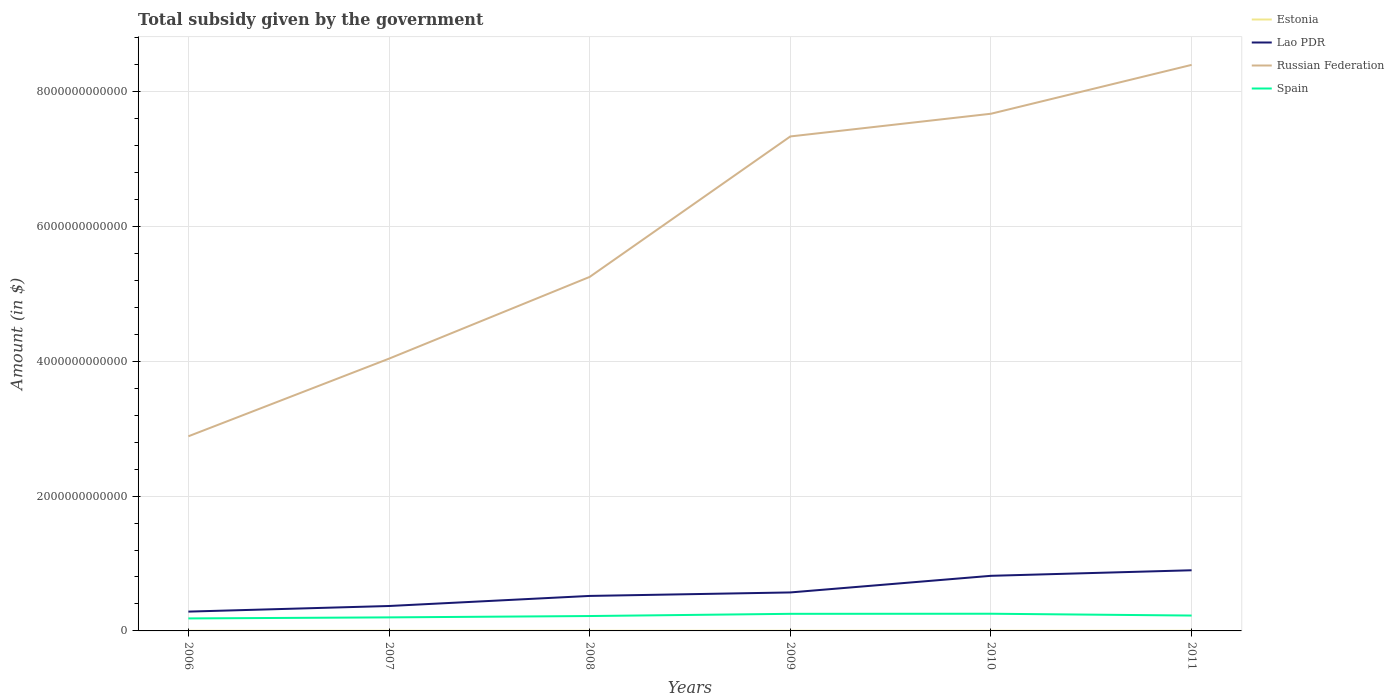Across all years, what is the maximum total revenue collected by the government in Lao PDR?
Ensure brevity in your answer.  2.87e+11. In which year was the total revenue collected by the government in Russian Federation maximum?
Give a very brief answer. 2006. What is the total total revenue collected by the government in Estonia in the graph?
Give a very brief answer. 3.53e+08. What is the difference between the highest and the second highest total revenue collected by the government in Lao PDR?
Keep it short and to the point. 6.13e+11. What is the difference between the highest and the lowest total revenue collected by the government in Estonia?
Make the answer very short. 2. Is the total revenue collected by the government in Estonia strictly greater than the total revenue collected by the government in Lao PDR over the years?
Your response must be concise. Yes. How many lines are there?
Provide a succinct answer. 4. What is the difference between two consecutive major ticks on the Y-axis?
Your answer should be compact. 2.00e+12. Does the graph contain any zero values?
Provide a short and direct response. No. Where does the legend appear in the graph?
Offer a very short reply. Top right. How many legend labels are there?
Ensure brevity in your answer.  4. How are the legend labels stacked?
Keep it short and to the point. Vertical. What is the title of the graph?
Ensure brevity in your answer.  Total subsidy given by the government. What is the label or title of the X-axis?
Your answer should be compact. Years. What is the label or title of the Y-axis?
Keep it short and to the point. Amount (in $). What is the Amount (in $) of Estonia in 2006?
Offer a very short reply. 2.17e+09. What is the Amount (in $) of Lao PDR in 2006?
Your answer should be very brief. 2.87e+11. What is the Amount (in $) in Russian Federation in 2006?
Offer a very short reply. 2.89e+12. What is the Amount (in $) in Spain in 2006?
Make the answer very short. 1.85e+11. What is the Amount (in $) in Estonia in 2007?
Make the answer very short. 2.59e+09. What is the Amount (in $) of Lao PDR in 2007?
Give a very brief answer. 3.70e+11. What is the Amount (in $) in Russian Federation in 2007?
Make the answer very short. 4.04e+12. What is the Amount (in $) of Spain in 2007?
Your response must be concise. 2.01e+11. What is the Amount (in $) in Estonia in 2008?
Ensure brevity in your answer.  2.03e+09. What is the Amount (in $) of Lao PDR in 2008?
Your response must be concise. 5.19e+11. What is the Amount (in $) in Russian Federation in 2008?
Offer a very short reply. 5.25e+12. What is the Amount (in $) of Spain in 2008?
Give a very brief answer. 2.21e+11. What is the Amount (in $) of Estonia in 2009?
Make the answer very short. 2.23e+09. What is the Amount (in $) of Lao PDR in 2009?
Keep it short and to the point. 5.71e+11. What is the Amount (in $) in Russian Federation in 2009?
Your answer should be compact. 7.33e+12. What is the Amount (in $) in Spain in 2009?
Provide a succinct answer. 2.54e+11. What is the Amount (in $) in Estonia in 2010?
Offer a terse response. 2.18e+09. What is the Amount (in $) of Lao PDR in 2010?
Keep it short and to the point. 8.17e+11. What is the Amount (in $) in Russian Federation in 2010?
Provide a succinct answer. 7.67e+12. What is the Amount (in $) in Spain in 2010?
Ensure brevity in your answer.  2.55e+11. What is the Amount (in $) in Estonia in 2011?
Offer a terse response. 2.20e+09. What is the Amount (in $) of Lao PDR in 2011?
Provide a succinct answer. 9.00e+11. What is the Amount (in $) of Russian Federation in 2011?
Offer a terse response. 8.40e+12. What is the Amount (in $) in Spain in 2011?
Your answer should be very brief. 2.28e+11. Across all years, what is the maximum Amount (in $) of Estonia?
Keep it short and to the point. 2.59e+09. Across all years, what is the maximum Amount (in $) in Lao PDR?
Ensure brevity in your answer.  9.00e+11. Across all years, what is the maximum Amount (in $) in Russian Federation?
Make the answer very short. 8.40e+12. Across all years, what is the maximum Amount (in $) of Spain?
Your answer should be very brief. 2.55e+11. Across all years, what is the minimum Amount (in $) of Estonia?
Give a very brief answer. 2.03e+09. Across all years, what is the minimum Amount (in $) of Lao PDR?
Provide a short and direct response. 2.87e+11. Across all years, what is the minimum Amount (in $) in Russian Federation?
Keep it short and to the point. 2.89e+12. Across all years, what is the minimum Amount (in $) of Spain?
Your answer should be compact. 1.85e+11. What is the total Amount (in $) of Estonia in the graph?
Offer a very short reply. 1.34e+1. What is the total Amount (in $) of Lao PDR in the graph?
Your answer should be compact. 3.46e+12. What is the total Amount (in $) of Russian Federation in the graph?
Your answer should be very brief. 3.56e+13. What is the total Amount (in $) of Spain in the graph?
Your answer should be compact. 1.34e+12. What is the difference between the Amount (in $) in Estonia in 2006 and that in 2007?
Provide a succinct answer. -4.19e+08. What is the difference between the Amount (in $) in Lao PDR in 2006 and that in 2007?
Ensure brevity in your answer.  -8.32e+1. What is the difference between the Amount (in $) of Russian Federation in 2006 and that in 2007?
Offer a very short reply. -1.15e+12. What is the difference between the Amount (in $) of Spain in 2006 and that in 2007?
Your answer should be very brief. -1.56e+1. What is the difference between the Amount (in $) of Estonia in 2006 and that in 2008?
Offer a terse response. 1.40e+08. What is the difference between the Amount (in $) of Lao PDR in 2006 and that in 2008?
Provide a succinct answer. -2.33e+11. What is the difference between the Amount (in $) of Russian Federation in 2006 and that in 2008?
Make the answer very short. -2.36e+12. What is the difference between the Amount (in $) of Spain in 2006 and that in 2008?
Your response must be concise. -3.55e+1. What is the difference between the Amount (in $) of Estonia in 2006 and that in 2009?
Your answer should be very brief. -6.62e+07. What is the difference between the Amount (in $) in Lao PDR in 2006 and that in 2009?
Keep it short and to the point. -2.84e+11. What is the difference between the Amount (in $) in Russian Federation in 2006 and that in 2009?
Ensure brevity in your answer.  -4.45e+12. What is the difference between the Amount (in $) in Spain in 2006 and that in 2009?
Offer a very short reply. -6.81e+1. What is the difference between the Amount (in $) of Estonia in 2006 and that in 2010?
Your answer should be compact. -1.08e+07. What is the difference between the Amount (in $) in Lao PDR in 2006 and that in 2010?
Make the answer very short. -5.31e+11. What is the difference between the Amount (in $) in Russian Federation in 2006 and that in 2010?
Your answer should be very brief. -4.78e+12. What is the difference between the Amount (in $) in Spain in 2006 and that in 2010?
Provide a succinct answer. -6.94e+1. What is the difference between the Amount (in $) of Estonia in 2006 and that in 2011?
Ensure brevity in your answer.  -3.22e+07. What is the difference between the Amount (in $) of Lao PDR in 2006 and that in 2011?
Your answer should be compact. -6.13e+11. What is the difference between the Amount (in $) in Russian Federation in 2006 and that in 2011?
Offer a very short reply. -5.51e+12. What is the difference between the Amount (in $) of Spain in 2006 and that in 2011?
Provide a succinct answer. -4.26e+1. What is the difference between the Amount (in $) in Estonia in 2007 and that in 2008?
Your answer should be very brief. 5.59e+08. What is the difference between the Amount (in $) of Lao PDR in 2007 and that in 2008?
Ensure brevity in your answer.  -1.49e+11. What is the difference between the Amount (in $) in Russian Federation in 2007 and that in 2008?
Give a very brief answer. -1.21e+12. What is the difference between the Amount (in $) of Spain in 2007 and that in 2008?
Your response must be concise. -1.99e+1. What is the difference between the Amount (in $) of Estonia in 2007 and that in 2009?
Offer a very short reply. 3.53e+08. What is the difference between the Amount (in $) of Lao PDR in 2007 and that in 2009?
Your answer should be compact. -2.01e+11. What is the difference between the Amount (in $) of Russian Federation in 2007 and that in 2009?
Your answer should be compact. -3.30e+12. What is the difference between the Amount (in $) in Spain in 2007 and that in 2009?
Ensure brevity in your answer.  -5.25e+1. What is the difference between the Amount (in $) of Estonia in 2007 and that in 2010?
Provide a succinct answer. 4.08e+08. What is the difference between the Amount (in $) in Lao PDR in 2007 and that in 2010?
Offer a very short reply. -4.48e+11. What is the difference between the Amount (in $) in Russian Federation in 2007 and that in 2010?
Provide a succinct answer. -3.63e+12. What is the difference between the Amount (in $) of Spain in 2007 and that in 2010?
Offer a terse response. -5.38e+1. What is the difference between the Amount (in $) of Estonia in 2007 and that in 2011?
Provide a short and direct response. 3.87e+08. What is the difference between the Amount (in $) of Lao PDR in 2007 and that in 2011?
Give a very brief answer. -5.30e+11. What is the difference between the Amount (in $) in Russian Federation in 2007 and that in 2011?
Your answer should be very brief. -4.36e+12. What is the difference between the Amount (in $) of Spain in 2007 and that in 2011?
Your response must be concise. -2.70e+1. What is the difference between the Amount (in $) of Estonia in 2008 and that in 2009?
Keep it short and to the point. -2.07e+08. What is the difference between the Amount (in $) in Lao PDR in 2008 and that in 2009?
Your answer should be very brief. -5.17e+1. What is the difference between the Amount (in $) of Russian Federation in 2008 and that in 2009?
Make the answer very short. -2.08e+12. What is the difference between the Amount (in $) in Spain in 2008 and that in 2009?
Provide a succinct answer. -3.26e+1. What is the difference between the Amount (in $) of Estonia in 2008 and that in 2010?
Keep it short and to the point. -1.51e+08. What is the difference between the Amount (in $) of Lao PDR in 2008 and that in 2010?
Your answer should be compact. -2.98e+11. What is the difference between the Amount (in $) of Russian Federation in 2008 and that in 2010?
Provide a short and direct response. -2.42e+12. What is the difference between the Amount (in $) in Spain in 2008 and that in 2010?
Your answer should be very brief. -3.39e+1. What is the difference between the Amount (in $) in Estonia in 2008 and that in 2011?
Provide a succinct answer. -1.73e+08. What is the difference between the Amount (in $) in Lao PDR in 2008 and that in 2011?
Provide a succinct answer. -3.81e+11. What is the difference between the Amount (in $) of Russian Federation in 2008 and that in 2011?
Your answer should be very brief. -3.15e+12. What is the difference between the Amount (in $) of Spain in 2008 and that in 2011?
Offer a very short reply. -7.13e+09. What is the difference between the Amount (in $) in Estonia in 2009 and that in 2010?
Offer a terse response. 5.54e+07. What is the difference between the Amount (in $) in Lao PDR in 2009 and that in 2010?
Ensure brevity in your answer.  -2.47e+11. What is the difference between the Amount (in $) of Russian Federation in 2009 and that in 2010?
Offer a very short reply. -3.37e+11. What is the difference between the Amount (in $) in Spain in 2009 and that in 2010?
Offer a very short reply. -1.29e+09. What is the difference between the Amount (in $) of Estonia in 2009 and that in 2011?
Your answer should be compact. 3.40e+07. What is the difference between the Amount (in $) of Lao PDR in 2009 and that in 2011?
Keep it short and to the point. -3.29e+11. What is the difference between the Amount (in $) of Russian Federation in 2009 and that in 2011?
Provide a succinct answer. -1.06e+12. What is the difference between the Amount (in $) in Spain in 2009 and that in 2011?
Your answer should be compact. 2.55e+1. What is the difference between the Amount (in $) of Estonia in 2010 and that in 2011?
Offer a terse response. -2.14e+07. What is the difference between the Amount (in $) of Lao PDR in 2010 and that in 2011?
Make the answer very short. -8.24e+1. What is the difference between the Amount (in $) in Russian Federation in 2010 and that in 2011?
Provide a succinct answer. -7.25e+11. What is the difference between the Amount (in $) in Spain in 2010 and that in 2011?
Make the answer very short. 2.68e+1. What is the difference between the Amount (in $) of Estonia in 2006 and the Amount (in $) of Lao PDR in 2007?
Provide a short and direct response. -3.68e+11. What is the difference between the Amount (in $) of Estonia in 2006 and the Amount (in $) of Russian Federation in 2007?
Provide a short and direct response. -4.04e+12. What is the difference between the Amount (in $) in Estonia in 2006 and the Amount (in $) in Spain in 2007?
Offer a terse response. -1.99e+11. What is the difference between the Amount (in $) of Lao PDR in 2006 and the Amount (in $) of Russian Federation in 2007?
Make the answer very short. -3.75e+12. What is the difference between the Amount (in $) in Lao PDR in 2006 and the Amount (in $) in Spain in 2007?
Your response must be concise. 8.55e+1. What is the difference between the Amount (in $) of Russian Federation in 2006 and the Amount (in $) of Spain in 2007?
Your answer should be compact. 2.69e+12. What is the difference between the Amount (in $) in Estonia in 2006 and the Amount (in $) in Lao PDR in 2008?
Offer a terse response. -5.17e+11. What is the difference between the Amount (in $) in Estonia in 2006 and the Amount (in $) in Russian Federation in 2008?
Offer a terse response. -5.25e+12. What is the difference between the Amount (in $) of Estonia in 2006 and the Amount (in $) of Spain in 2008?
Make the answer very short. -2.19e+11. What is the difference between the Amount (in $) in Lao PDR in 2006 and the Amount (in $) in Russian Federation in 2008?
Your answer should be compact. -4.96e+12. What is the difference between the Amount (in $) in Lao PDR in 2006 and the Amount (in $) in Spain in 2008?
Offer a terse response. 6.56e+1. What is the difference between the Amount (in $) in Russian Federation in 2006 and the Amount (in $) in Spain in 2008?
Give a very brief answer. 2.67e+12. What is the difference between the Amount (in $) of Estonia in 2006 and the Amount (in $) of Lao PDR in 2009?
Offer a very short reply. -5.69e+11. What is the difference between the Amount (in $) of Estonia in 2006 and the Amount (in $) of Russian Federation in 2009?
Provide a short and direct response. -7.33e+12. What is the difference between the Amount (in $) in Estonia in 2006 and the Amount (in $) in Spain in 2009?
Offer a very short reply. -2.51e+11. What is the difference between the Amount (in $) in Lao PDR in 2006 and the Amount (in $) in Russian Federation in 2009?
Make the answer very short. -7.05e+12. What is the difference between the Amount (in $) of Lao PDR in 2006 and the Amount (in $) of Spain in 2009?
Offer a terse response. 3.30e+1. What is the difference between the Amount (in $) in Russian Federation in 2006 and the Amount (in $) in Spain in 2009?
Make the answer very short. 2.63e+12. What is the difference between the Amount (in $) in Estonia in 2006 and the Amount (in $) in Lao PDR in 2010?
Your response must be concise. -8.15e+11. What is the difference between the Amount (in $) in Estonia in 2006 and the Amount (in $) in Russian Federation in 2010?
Your answer should be very brief. -7.67e+12. What is the difference between the Amount (in $) in Estonia in 2006 and the Amount (in $) in Spain in 2010?
Your answer should be compact. -2.53e+11. What is the difference between the Amount (in $) in Lao PDR in 2006 and the Amount (in $) in Russian Federation in 2010?
Your response must be concise. -7.38e+12. What is the difference between the Amount (in $) in Lao PDR in 2006 and the Amount (in $) in Spain in 2010?
Offer a very short reply. 3.17e+1. What is the difference between the Amount (in $) of Russian Federation in 2006 and the Amount (in $) of Spain in 2010?
Offer a very short reply. 2.63e+12. What is the difference between the Amount (in $) of Estonia in 2006 and the Amount (in $) of Lao PDR in 2011?
Your response must be concise. -8.98e+11. What is the difference between the Amount (in $) of Estonia in 2006 and the Amount (in $) of Russian Federation in 2011?
Give a very brief answer. -8.39e+12. What is the difference between the Amount (in $) of Estonia in 2006 and the Amount (in $) of Spain in 2011?
Offer a terse response. -2.26e+11. What is the difference between the Amount (in $) of Lao PDR in 2006 and the Amount (in $) of Russian Federation in 2011?
Offer a terse response. -8.11e+12. What is the difference between the Amount (in $) in Lao PDR in 2006 and the Amount (in $) in Spain in 2011?
Give a very brief answer. 5.84e+1. What is the difference between the Amount (in $) in Russian Federation in 2006 and the Amount (in $) in Spain in 2011?
Make the answer very short. 2.66e+12. What is the difference between the Amount (in $) of Estonia in 2007 and the Amount (in $) of Lao PDR in 2008?
Offer a terse response. -5.17e+11. What is the difference between the Amount (in $) of Estonia in 2007 and the Amount (in $) of Russian Federation in 2008?
Offer a very short reply. -5.25e+12. What is the difference between the Amount (in $) of Estonia in 2007 and the Amount (in $) of Spain in 2008?
Offer a terse response. -2.18e+11. What is the difference between the Amount (in $) in Lao PDR in 2007 and the Amount (in $) in Russian Federation in 2008?
Your answer should be compact. -4.88e+12. What is the difference between the Amount (in $) of Lao PDR in 2007 and the Amount (in $) of Spain in 2008?
Offer a terse response. 1.49e+11. What is the difference between the Amount (in $) in Russian Federation in 2007 and the Amount (in $) in Spain in 2008?
Make the answer very short. 3.82e+12. What is the difference between the Amount (in $) of Estonia in 2007 and the Amount (in $) of Lao PDR in 2009?
Make the answer very short. -5.68e+11. What is the difference between the Amount (in $) in Estonia in 2007 and the Amount (in $) in Russian Federation in 2009?
Give a very brief answer. -7.33e+12. What is the difference between the Amount (in $) in Estonia in 2007 and the Amount (in $) in Spain in 2009?
Provide a short and direct response. -2.51e+11. What is the difference between the Amount (in $) in Lao PDR in 2007 and the Amount (in $) in Russian Federation in 2009?
Keep it short and to the point. -6.96e+12. What is the difference between the Amount (in $) of Lao PDR in 2007 and the Amount (in $) of Spain in 2009?
Provide a short and direct response. 1.16e+11. What is the difference between the Amount (in $) in Russian Federation in 2007 and the Amount (in $) in Spain in 2009?
Your answer should be very brief. 3.78e+12. What is the difference between the Amount (in $) in Estonia in 2007 and the Amount (in $) in Lao PDR in 2010?
Make the answer very short. -8.15e+11. What is the difference between the Amount (in $) of Estonia in 2007 and the Amount (in $) of Russian Federation in 2010?
Provide a succinct answer. -7.67e+12. What is the difference between the Amount (in $) in Estonia in 2007 and the Amount (in $) in Spain in 2010?
Ensure brevity in your answer.  -2.52e+11. What is the difference between the Amount (in $) of Lao PDR in 2007 and the Amount (in $) of Russian Federation in 2010?
Provide a succinct answer. -7.30e+12. What is the difference between the Amount (in $) in Lao PDR in 2007 and the Amount (in $) in Spain in 2010?
Your answer should be compact. 1.15e+11. What is the difference between the Amount (in $) of Russian Federation in 2007 and the Amount (in $) of Spain in 2010?
Ensure brevity in your answer.  3.78e+12. What is the difference between the Amount (in $) of Estonia in 2007 and the Amount (in $) of Lao PDR in 2011?
Ensure brevity in your answer.  -8.97e+11. What is the difference between the Amount (in $) of Estonia in 2007 and the Amount (in $) of Russian Federation in 2011?
Give a very brief answer. -8.39e+12. What is the difference between the Amount (in $) in Estonia in 2007 and the Amount (in $) in Spain in 2011?
Make the answer very short. -2.26e+11. What is the difference between the Amount (in $) in Lao PDR in 2007 and the Amount (in $) in Russian Federation in 2011?
Offer a terse response. -8.03e+12. What is the difference between the Amount (in $) of Lao PDR in 2007 and the Amount (in $) of Spain in 2011?
Your answer should be compact. 1.42e+11. What is the difference between the Amount (in $) of Russian Federation in 2007 and the Amount (in $) of Spain in 2011?
Provide a short and direct response. 3.81e+12. What is the difference between the Amount (in $) of Estonia in 2008 and the Amount (in $) of Lao PDR in 2009?
Give a very brief answer. -5.69e+11. What is the difference between the Amount (in $) in Estonia in 2008 and the Amount (in $) in Russian Federation in 2009?
Provide a succinct answer. -7.33e+12. What is the difference between the Amount (in $) in Estonia in 2008 and the Amount (in $) in Spain in 2009?
Give a very brief answer. -2.52e+11. What is the difference between the Amount (in $) in Lao PDR in 2008 and the Amount (in $) in Russian Federation in 2009?
Offer a terse response. -6.82e+12. What is the difference between the Amount (in $) of Lao PDR in 2008 and the Amount (in $) of Spain in 2009?
Make the answer very short. 2.66e+11. What is the difference between the Amount (in $) of Russian Federation in 2008 and the Amount (in $) of Spain in 2009?
Give a very brief answer. 5.00e+12. What is the difference between the Amount (in $) of Estonia in 2008 and the Amount (in $) of Lao PDR in 2010?
Your response must be concise. -8.15e+11. What is the difference between the Amount (in $) in Estonia in 2008 and the Amount (in $) in Russian Federation in 2010?
Give a very brief answer. -7.67e+12. What is the difference between the Amount (in $) of Estonia in 2008 and the Amount (in $) of Spain in 2010?
Ensure brevity in your answer.  -2.53e+11. What is the difference between the Amount (in $) of Lao PDR in 2008 and the Amount (in $) of Russian Federation in 2010?
Your answer should be very brief. -7.15e+12. What is the difference between the Amount (in $) of Lao PDR in 2008 and the Amount (in $) of Spain in 2010?
Ensure brevity in your answer.  2.64e+11. What is the difference between the Amount (in $) of Russian Federation in 2008 and the Amount (in $) of Spain in 2010?
Offer a very short reply. 5.00e+12. What is the difference between the Amount (in $) in Estonia in 2008 and the Amount (in $) in Lao PDR in 2011?
Offer a terse response. -8.98e+11. What is the difference between the Amount (in $) of Estonia in 2008 and the Amount (in $) of Russian Federation in 2011?
Your response must be concise. -8.39e+12. What is the difference between the Amount (in $) of Estonia in 2008 and the Amount (in $) of Spain in 2011?
Offer a very short reply. -2.26e+11. What is the difference between the Amount (in $) of Lao PDR in 2008 and the Amount (in $) of Russian Federation in 2011?
Provide a succinct answer. -7.88e+12. What is the difference between the Amount (in $) of Lao PDR in 2008 and the Amount (in $) of Spain in 2011?
Provide a short and direct response. 2.91e+11. What is the difference between the Amount (in $) of Russian Federation in 2008 and the Amount (in $) of Spain in 2011?
Offer a terse response. 5.02e+12. What is the difference between the Amount (in $) of Estonia in 2009 and the Amount (in $) of Lao PDR in 2010?
Provide a succinct answer. -8.15e+11. What is the difference between the Amount (in $) in Estonia in 2009 and the Amount (in $) in Russian Federation in 2010?
Make the answer very short. -7.67e+12. What is the difference between the Amount (in $) of Estonia in 2009 and the Amount (in $) of Spain in 2010?
Provide a succinct answer. -2.53e+11. What is the difference between the Amount (in $) of Lao PDR in 2009 and the Amount (in $) of Russian Federation in 2010?
Offer a very short reply. -7.10e+12. What is the difference between the Amount (in $) of Lao PDR in 2009 and the Amount (in $) of Spain in 2010?
Give a very brief answer. 3.16e+11. What is the difference between the Amount (in $) of Russian Federation in 2009 and the Amount (in $) of Spain in 2010?
Your answer should be compact. 7.08e+12. What is the difference between the Amount (in $) of Estonia in 2009 and the Amount (in $) of Lao PDR in 2011?
Your answer should be very brief. -8.98e+11. What is the difference between the Amount (in $) of Estonia in 2009 and the Amount (in $) of Russian Federation in 2011?
Make the answer very short. -8.39e+12. What is the difference between the Amount (in $) of Estonia in 2009 and the Amount (in $) of Spain in 2011?
Give a very brief answer. -2.26e+11. What is the difference between the Amount (in $) of Lao PDR in 2009 and the Amount (in $) of Russian Federation in 2011?
Give a very brief answer. -7.83e+12. What is the difference between the Amount (in $) in Lao PDR in 2009 and the Amount (in $) in Spain in 2011?
Make the answer very short. 3.43e+11. What is the difference between the Amount (in $) of Russian Federation in 2009 and the Amount (in $) of Spain in 2011?
Provide a short and direct response. 7.11e+12. What is the difference between the Amount (in $) of Estonia in 2010 and the Amount (in $) of Lao PDR in 2011?
Ensure brevity in your answer.  -8.98e+11. What is the difference between the Amount (in $) of Estonia in 2010 and the Amount (in $) of Russian Federation in 2011?
Offer a very short reply. -8.39e+12. What is the difference between the Amount (in $) of Estonia in 2010 and the Amount (in $) of Spain in 2011?
Make the answer very short. -2.26e+11. What is the difference between the Amount (in $) of Lao PDR in 2010 and the Amount (in $) of Russian Federation in 2011?
Offer a very short reply. -7.58e+12. What is the difference between the Amount (in $) of Lao PDR in 2010 and the Amount (in $) of Spain in 2011?
Your answer should be compact. 5.89e+11. What is the difference between the Amount (in $) in Russian Federation in 2010 and the Amount (in $) in Spain in 2011?
Offer a very short reply. 7.44e+12. What is the average Amount (in $) in Estonia per year?
Your response must be concise. 2.23e+09. What is the average Amount (in $) of Lao PDR per year?
Offer a very short reply. 5.77e+11. What is the average Amount (in $) in Russian Federation per year?
Your answer should be compact. 5.93e+12. What is the average Amount (in $) in Spain per year?
Your answer should be compact. 2.24e+11. In the year 2006, what is the difference between the Amount (in $) in Estonia and Amount (in $) in Lao PDR?
Offer a terse response. -2.84e+11. In the year 2006, what is the difference between the Amount (in $) in Estonia and Amount (in $) in Russian Federation?
Provide a short and direct response. -2.88e+12. In the year 2006, what is the difference between the Amount (in $) in Estonia and Amount (in $) in Spain?
Give a very brief answer. -1.83e+11. In the year 2006, what is the difference between the Amount (in $) of Lao PDR and Amount (in $) of Russian Federation?
Your response must be concise. -2.60e+12. In the year 2006, what is the difference between the Amount (in $) in Lao PDR and Amount (in $) in Spain?
Keep it short and to the point. 1.01e+11. In the year 2006, what is the difference between the Amount (in $) of Russian Federation and Amount (in $) of Spain?
Provide a short and direct response. 2.70e+12. In the year 2007, what is the difference between the Amount (in $) of Estonia and Amount (in $) of Lao PDR?
Make the answer very short. -3.67e+11. In the year 2007, what is the difference between the Amount (in $) of Estonia and Amount (in $) of Russian Federation?
Give a very brief answer. -4.04e+12. In the year 2007, what is the difference between the Amount (in $) of Estonia and Amount (in $) of Spain?
Offer a terse response. -1.98e+11. In the year 2007, what is the difference between the Amount (in $) in Lao PDR and Amount (in $) in Russian Federation?
Make the answer very short. -3.67e+12. In the year 2007, what is the difference between the Amount (in $) of Lao PDR and Amount (in $) of Spain?
Make the answer very short. 1.69e+11. In the year 2007, what is the difference between the Amount (in $) of Russian Federation and Amount (in $) of Spain?
Give a very brief answer. 3.84e+12. In the year 2008, what is the difference between the Amount (in $) in Estonia and Amount (in $) in Lao PDR?
Give a very brief answer. -5.17e+11. In the year 2008, what is the difference between the Amount (in $) of Estonia and Amount (in $) of Russian Federation?
Give a very brief answer. -5.25e+12. In the year 2008, what is the difference between the Amount (in $) in Estonia and Amount (in $) in Spain?
Offer a very short reply. -2.19e+11. In the year 2008, what is the difference between the Amount (in $) in Lao PDR and Amount (in $) in Russian Federation?
Ensure brevity in your answer.  -4.73e+12. In the year 2008, what is the difference between the Amount (in $) of Lao PDR and Amount (in $) of Spain?
Your response must be concise. 2.98e+11. In the year 2008, what is the difference between the Amount (in $) of Russian Federation and Amount (in $) of Spain?
Your response must be concise. 5.03e+12. In the year 2009, what is the difference between the Amount (in $) of Estonia and Amount (in $) of Lao PDR?
Offer a terse response. -5.69e+11. In the year 2009, what is the difference between the Amount (in $) of Estonia and Amount (in $) of Russian Federation?
Ensure brevity in your answer.  -7.33e+12. In the year 2009, what is the difference between the Amount (in $) of Estonia and Amount (in $) of Spain?
Offer a terse response. -2.51e+11. In the year 2009, what is the difference between the Amount (in $) in Lao PDR and Amount (in $) in Russian Federation?
Offer a terse response. -6.76e+12. In the year 2009, what is the difference between the Amount (in $) of Lao PDR and Amount (in $) of Spain?
Ensure brevity in your answer.  3.17e+11. In the year 2009, what is the difference between the Amount (in $) of Russian Federation and Amount (in $) of Spain?
Provide a succinct answer. 7.08e+12. In the year 2010, what is the difference between the Amount (in $) in Estonia and Amount (in $) in Lao PDR?
Make the answer very short. -8.15e+11. In the year 2010, what is the difference between the Amount (in $) of Estonia and Amount (in $) of Russian Federation?
Keep it short and to the point. -7.67e+12. In the year 2010, what is the difference between the Amount (in $) of Estonia and Amount (in $) of Spain?
Your answer should be very brief. -2.53e+11. In the year 2010, what is the difference between the Amount (in $) in Lao PDR and Amount (in $) in Russian Federation?
Make the answer very short. -6.85e+12. In the year 2010, what is the difference between the Amount (in $) in Lao PDR and Amount (in $) in Spain?
Your response must be concise. 5.62e+11. In the year 2010, what is the difference between the Amount (in $) of Russian Federation and Amount (in $) of Spain?
Provide a short and direct response. 7.42e+12. In the year 2011, what is the difference between the Amount (in $) of Estonia and Amount (in $) of Lao PDR?
Provide a short and direct response. -8.98e+11. In the year 2011, what is the difference between the Amount (in $) of Estonia and Amount (in $) of Russian Federation?
Your response must be concise. -8.39e+12. In the year 2011, what is the difference between the Amount (in $) of Estonia and Amount (in $) of Spain?
Offer a terse response. -2.26e+11. In the year 2011, what is the difference between the Amount (in $) in Lao PDR and Amount (in $) in Russian Federation?
Offer a very short reply. -7.50e+12. In the year 2011, what is the difference between the Amount (in $) in Lao PDR and Amount (in $) in Spain?
Provide a short and direct response. 6.72e+11. In the year 2011, what is the difference between the Amount (in $) of Russian Federation and Amount (in $) of Spain?
Make the answer very short. 8.17e+12. What is the ratio of the Amount (in $) in Estonia in 2006 to that in 2007?
Provide a short and direct response. 0.84. What is the ratio of the Amount (in $) in Lao PDR in 2006 to that in 2007?
Offer a terse response. 0.78. What is the ratio of the Amount (in $) in Russian Federation in 2006 to that in 2007?
Ensure brevity in your answer.  0.71. What is the ratio of the Amount (in $) of Spain in 2006 to that in 2007?
Your answer should be compact. 0.92. What is the ratio of the Amount (in $) of Estonia in 2006 to that in 2008?
Your answer should be very brief. 1.07. What is the ratio of the Amount (in $) of Lao PDR in 2006 to that in 2008?
Your answer should be compact. 0.55. What is the ratio of the Amount (in $) in Russian Federation in 2006 to that in 2008?
Provide a short and direct response. 0.55. What is the ratio of the Amount (in $) of Spain in 2006 to that in 2008?
Your answer should be very brief. 0.84. What is the ratio of the Amount (in $) in Estonia in 2006 to that in 2009?
Ensure brevity in your answer.  0.97. What is the ratio of the Amount (in $) in Lao PDR in 2006 to that in 2009?
Give a very brief answer. 0.5. What is the ratio of the Amount (in $) of Russian Federation in 2006 to that in 2009?
Offer a very short reply. 0.39. What is the ratio of the Amount (in $) in Spain in 2006 to that in 2009?
Provide a short and direct response. 0.73. What is the ratio of the Amount (in $) of Estonia in 2006 to that in 2010?
Provide a short and direct response. 0.99. What is the ratio of the Amount (in $) in Lao PDR in 2006 to that in 2010?
Keep it short and to the point. 0.35. What is the ratio of the Amount (in $) of Russian Federation in 2006 to that in 2010?
Make the answer very short. 0.38. What is the ratio of the Amount (in $) of Spain in 2006 to that in 2010?
Your answer should be very brief. 0.73. What is the ratio of the Amount (in $) of Estonia in 2006 to that in 2011?
Make the answer very short. 0.99. What is the ratio of the Amount (in $) of Lao PDR in 2006 to that in 2011?
Keep it short and to the point. 0.32. What is the ratio of the Amount (in $) in Russian Federation in 2006 to that in 2011?
Your response must be concise. 0.34. What is the ratio of the Amount (in $) of Spain in 2006 to that in 2011?
Ensure brevity in your answer.  0.81. What is the ratio of the Amount (in $) of Estonia in 2007 to that in 2008?
Offer a very short reply. 1.28. What is the ratio of the Amount (in $) in Lao PDR in 2007 to that in 2008?
Your answer should be very brief. 0.71. What is the ratio of the Amount (in $) of Russian Federation in 2007 to that in 2008?
Give a very brief answer. 0.77. What is the ratio of the Amount (in $) in Spain in 2007 to that in 2008?
Your response must be concise. 0.91. What is the ratio of the Amount (in $) of Estonia in 2007 to that in 2009?
Your response must be concise. 1.16. What is the ratio of the Amount (in $) in Lao PDR in 2007 to that in 2009?
Provide a succinct answer. 0.65. What is the ratio of the Amount (in $) of Russian Federation in 2007 to that in 2009?
Your answer should be very brief. 0.55. What is the ratio of the Amount (in $) in Spain in 2007 to that in 2009?
Your answer should be compact. 0.79. What is the ratio of the Amount (in $) of Estonia in 2007 to that in 2010?
Ensure brevity in your answer.  1.19. What is the ratio of the Amount (in $) of Lao PDR in 2007 to that in 2010?
Ensure brevity in your answer.  0.45. What is the ratio of the Amount (in $) in Russian Federation in 2007 to that in 2010?
Keep it short and to the point. 0.53. What is the ratio of the Amount (in $) of Spain in 2007 to that in 2010?
Give a very brief answer. 0.79. What is the ratio of the Amount (in $) in Estonia in 2007 to that in 2011?
Provide a succinct answer. 1.18. What is the ratio of the Amount (in $) in Lao PDR in 2007 to that in 2011?
Provide a short and direct response. 0.41. What is the ratio of the Amount (in $) of Russian Federation in 2007 to that in 2011?
Offer a terse response. 0.48. What is the ratio of the Amount (in $) of Spain in 2007 to that in 2011?
Your response must be concise. 0.88. What is the ratio of the Amount (in $) of Estonia in 2008 to that in 2009?
Offer a terse response. 0.91. What is the ratio of the Amount (in $) of Lao PDR in 2008 to that in 2009?
Offer a terse response. 0.91. What is the ratio of the Amount (in $) of Russian Federation in 2008 to that in 2009?
Keep it short and to the point. 0.72. What is the ratio of the Amount (in $) in Spain in 2008 to that in 2009?
Give a very brief answer. 0.87. What is the ratio of the Amount (in $) of Estonia in 2008 to that in 2010?
Give a very brief answer. 0.93. What is the ratio of the Amount (in $) of Lao PDR in 2008 to that in 2010?
Your response must be concise. 0.64. What is the ratio of the Amount (in $) of Russian Federation in 2008 to that in 2010?
Offer a very short reply. 0.68. What is the ratio of the Amount (in $) of Spain in 2008 to that in 2010?
Offer a very short reply. 0.87. What is the ratio of the Amount (in $) of Estonia in 2008 to that in 2011?
Your answer should be compact. 0.92. What is the ratio of the Amount (in $) of Lao PDR in 2008 to that in 2011?
Make the answer very short. 0.58. What is the ratio of the Amount (in $) of Russian Federation in 2008 to that in 2011?
Your response must be concise. 0.63. What is the ratio of the Amount (in $) in Spain in 2008 to that in 2011?
Your answer should be very brief. 0.97. What is the ratio of the Amount (in $) of Estonia in 2009 to that in 2010?
Provide a succinct answer. 1.03. What is the ratio of the Amount (in $) of Lao PDR in 2009 to that in 2010?
Ensure brevity in your answer.  0.7. What is the ratio of the Amount (in $) in Russian Federation in 2009 to that in 2010?
Keep it short and to the point. 0.96. What is the ratio of the Amount (in $) in Estonia in 2009 to that in 2011?
Provide a succinct answer. 1.02. What is the ratio of the Amount (in $) in Lao PDR in 2009 to that in 2011?
Your response must be concise. 0.63. What is the ratio of the Amount (in $) of Russian Federation in 2009 to that in 2011?
Give a very brief answer. 0.87. What is the ratio of the Amount (in $) in Spain in 2009 to that in 2011?
Offer a terse response. 1.11. What is the ratio of the Amount (in $) of Estonia in 2010 to that in 2011?
Offer a terse response. 0.99. What is the ratio of the Amount (in $) in Lao PDR in 2010 to that in 2011?
Your answer should be compact. 0.91. What is the ratio of the Amount (in $) of Russian Federation in 2010 to that in 2011?
Keep it short and to the point. 0.91. What is the ratio of the Amount (in $) in Spain in 2010 to that in 2011?
Give a very brief answer. 1.12. What is the difference between the highest and the second highest Amount (in $) of Estonia?
Offer a very short reply. 3.53e+08. What is the difference between the highest and the second highest Amount (in $) of Lao PDR?
Ensure brevity in your answer.  8.24e+1. What is the difference between the highest and the second highest Amount (in $) of Russian Federation?
Your response must be concise. 7.25e+11. What is the difference between the highest and the second highest Amount (in $) of Spain?
Offer a terse response. 1.29e+09. What is the difference between the highest and the lowest Amount (in $) of Estonia?
Give a very brief answer. 5.59e+08. What is the difference between the highest and the lowest Amount (in $) of Lao PDR?
Provide a short and direct response. 6.13e+11. What is the difference between the highest and the lowest Amount (in $) in Russian Federation?
Your answer should be very brief. 5.51e+12. What is the difference between the highest and the lowest Amount (in $) in Spain?
Your response must be concise. 6.94e+1. 